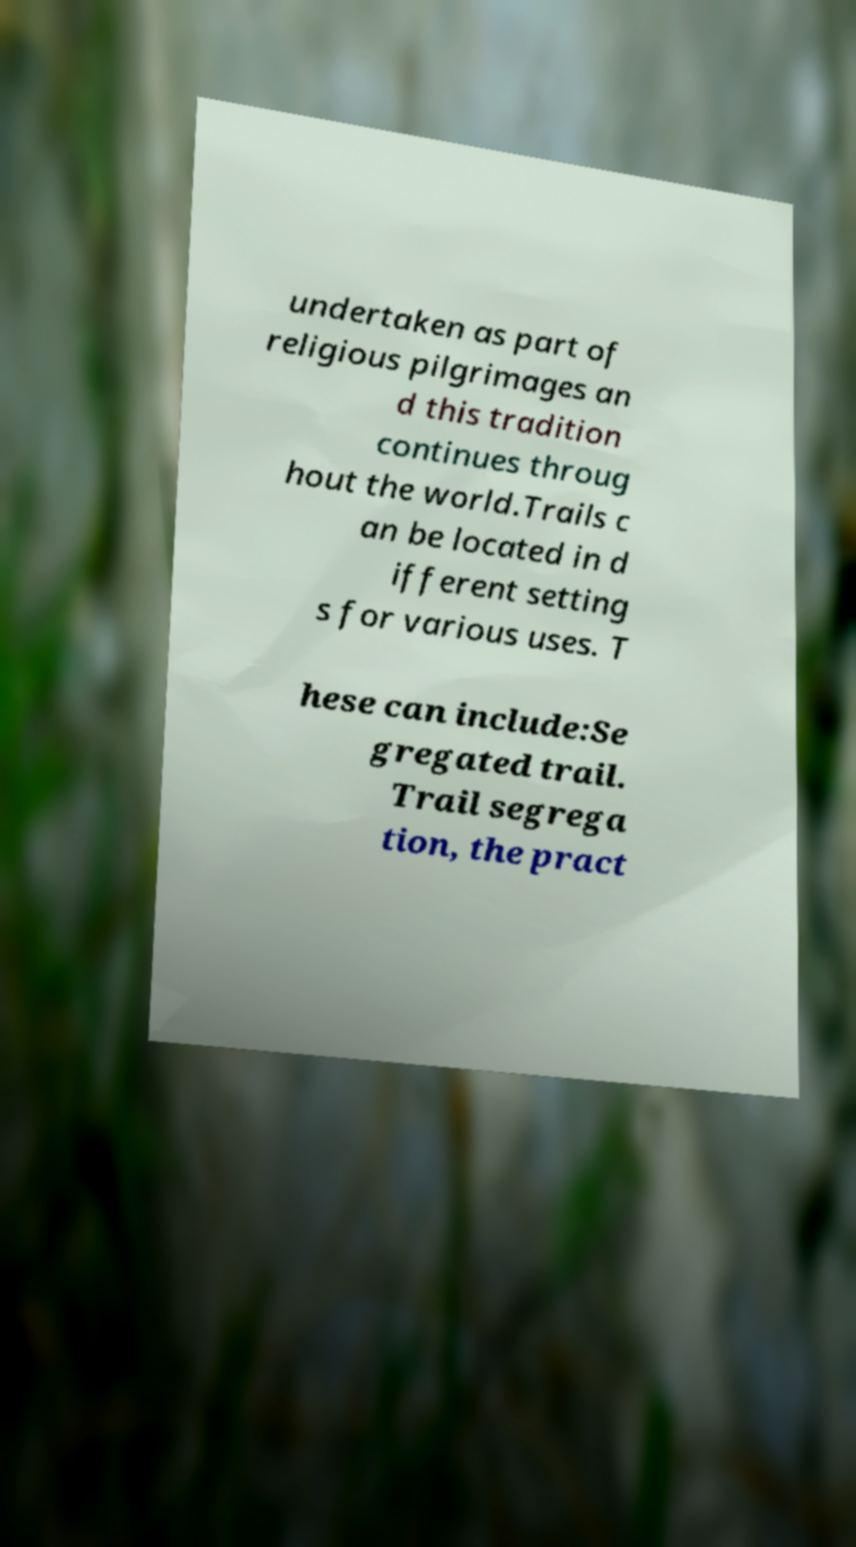Please identify and transcribe the text found in this image. undertaken as part of religious pilgrimages an d this tradition continues throug hout the world.Trails c an be located in d ifferent setting s for various uses. T hese can include:Se gregated trail. Trail segrega tion, the pract 